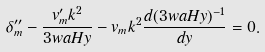Convert formula to latex. <formula><loc_0><loc_0><loc_500><loc_500>\delta ^ { \prime \prime } _ { m } - \frac { v ^ { \prime } _ { m } k ^ { 2 } } { 3 w a H y } - v _ { m } k ^ { 2 } \frac { d ( 3 w a H y ) ^ { - 1 } } { d y } = 0 .</formula> 